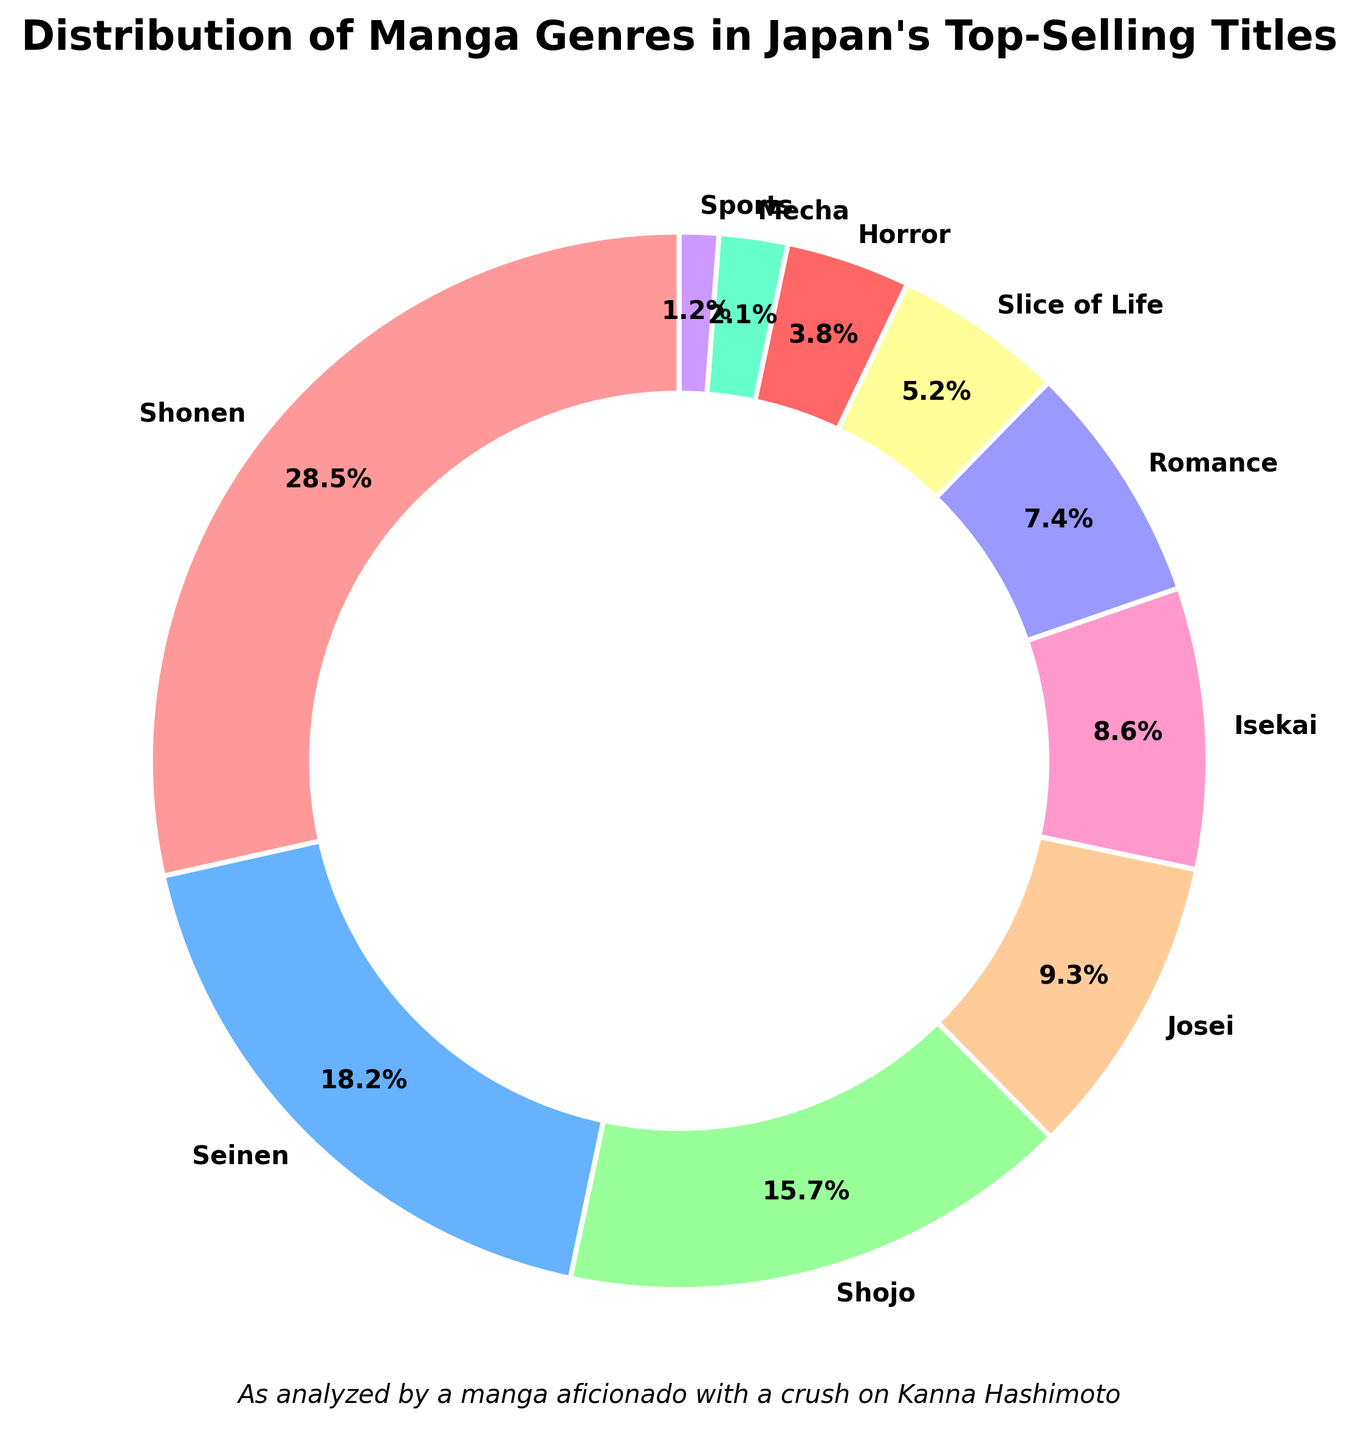What genre has the largest share of top-selling manga titles in Japan? To determine the genre with the largest share, refer to the wedge of the pie chart that covers the most area.
Answer: Shonen How many genres contribute less than 10% to the top-selling manga titles in Japan? Look at each wedge label of the pie chart. Count the wedges that have percentages less than 10%.
Answer: 6 What is the combined percentage of Shonen and Seinen genres in top-selling manga titles? Add the percentages of the Shonen (28.5%) and Seinen (18.2%) genres: 28.5 + 18.2.
Answer: 46.7% Is Shojo genre's share larger than Josei genre's share? Compare the percentage of the Shojo genre (15.7%) to the percentage of the Josei genre (9.3%).
Answer: Yes Which genres together make up the smallest 10% of the pie chart? Identify the genres with percentages adding up to 10%, starting from the smallest (Sports, 1.2%; Mecha, 2.1%; Horror, 3.8%; total = 7.1%) and then the next smallest (Slice of Life, 5.2%; total = 12.3%, so it overshoots slightly).
Answer: Sports and Mecha What is the percentage difference between the genres Shonen and Shojo? Subtract the Shojo genre percentage (15.7%) from the Shonen genre percentage (28.5%): 28.5 - 15.7.
Answer: 12.8% How does the slice representing Isekai compare visually to those of Shojo and Josei? To compare, note the size and label on each corresponding wedge of the pie chart. The Isekai wedge (8.6%) is smaller than Shojo (15.7%) but just slightly smaller than Josei (9.3%).
Answer: Smaller than Shojo, slightly smaller than Josei What share does Romance genre have relative to the entire pie chart? Look at the label for Romance on the pie chart to find its percentage: 7.4%.
Answer: 7.4% Which genres occupy positions fourth and fifth by percentage of top-selling manga titles? Identify the top percentages in descending order: Shonen (28.5%), Seinen (18.2%), Shojo (15.7%), thus fourth and fifth are Josei (9.3%) and Isekai (8.6%).
Answer: Josei and Isekai 